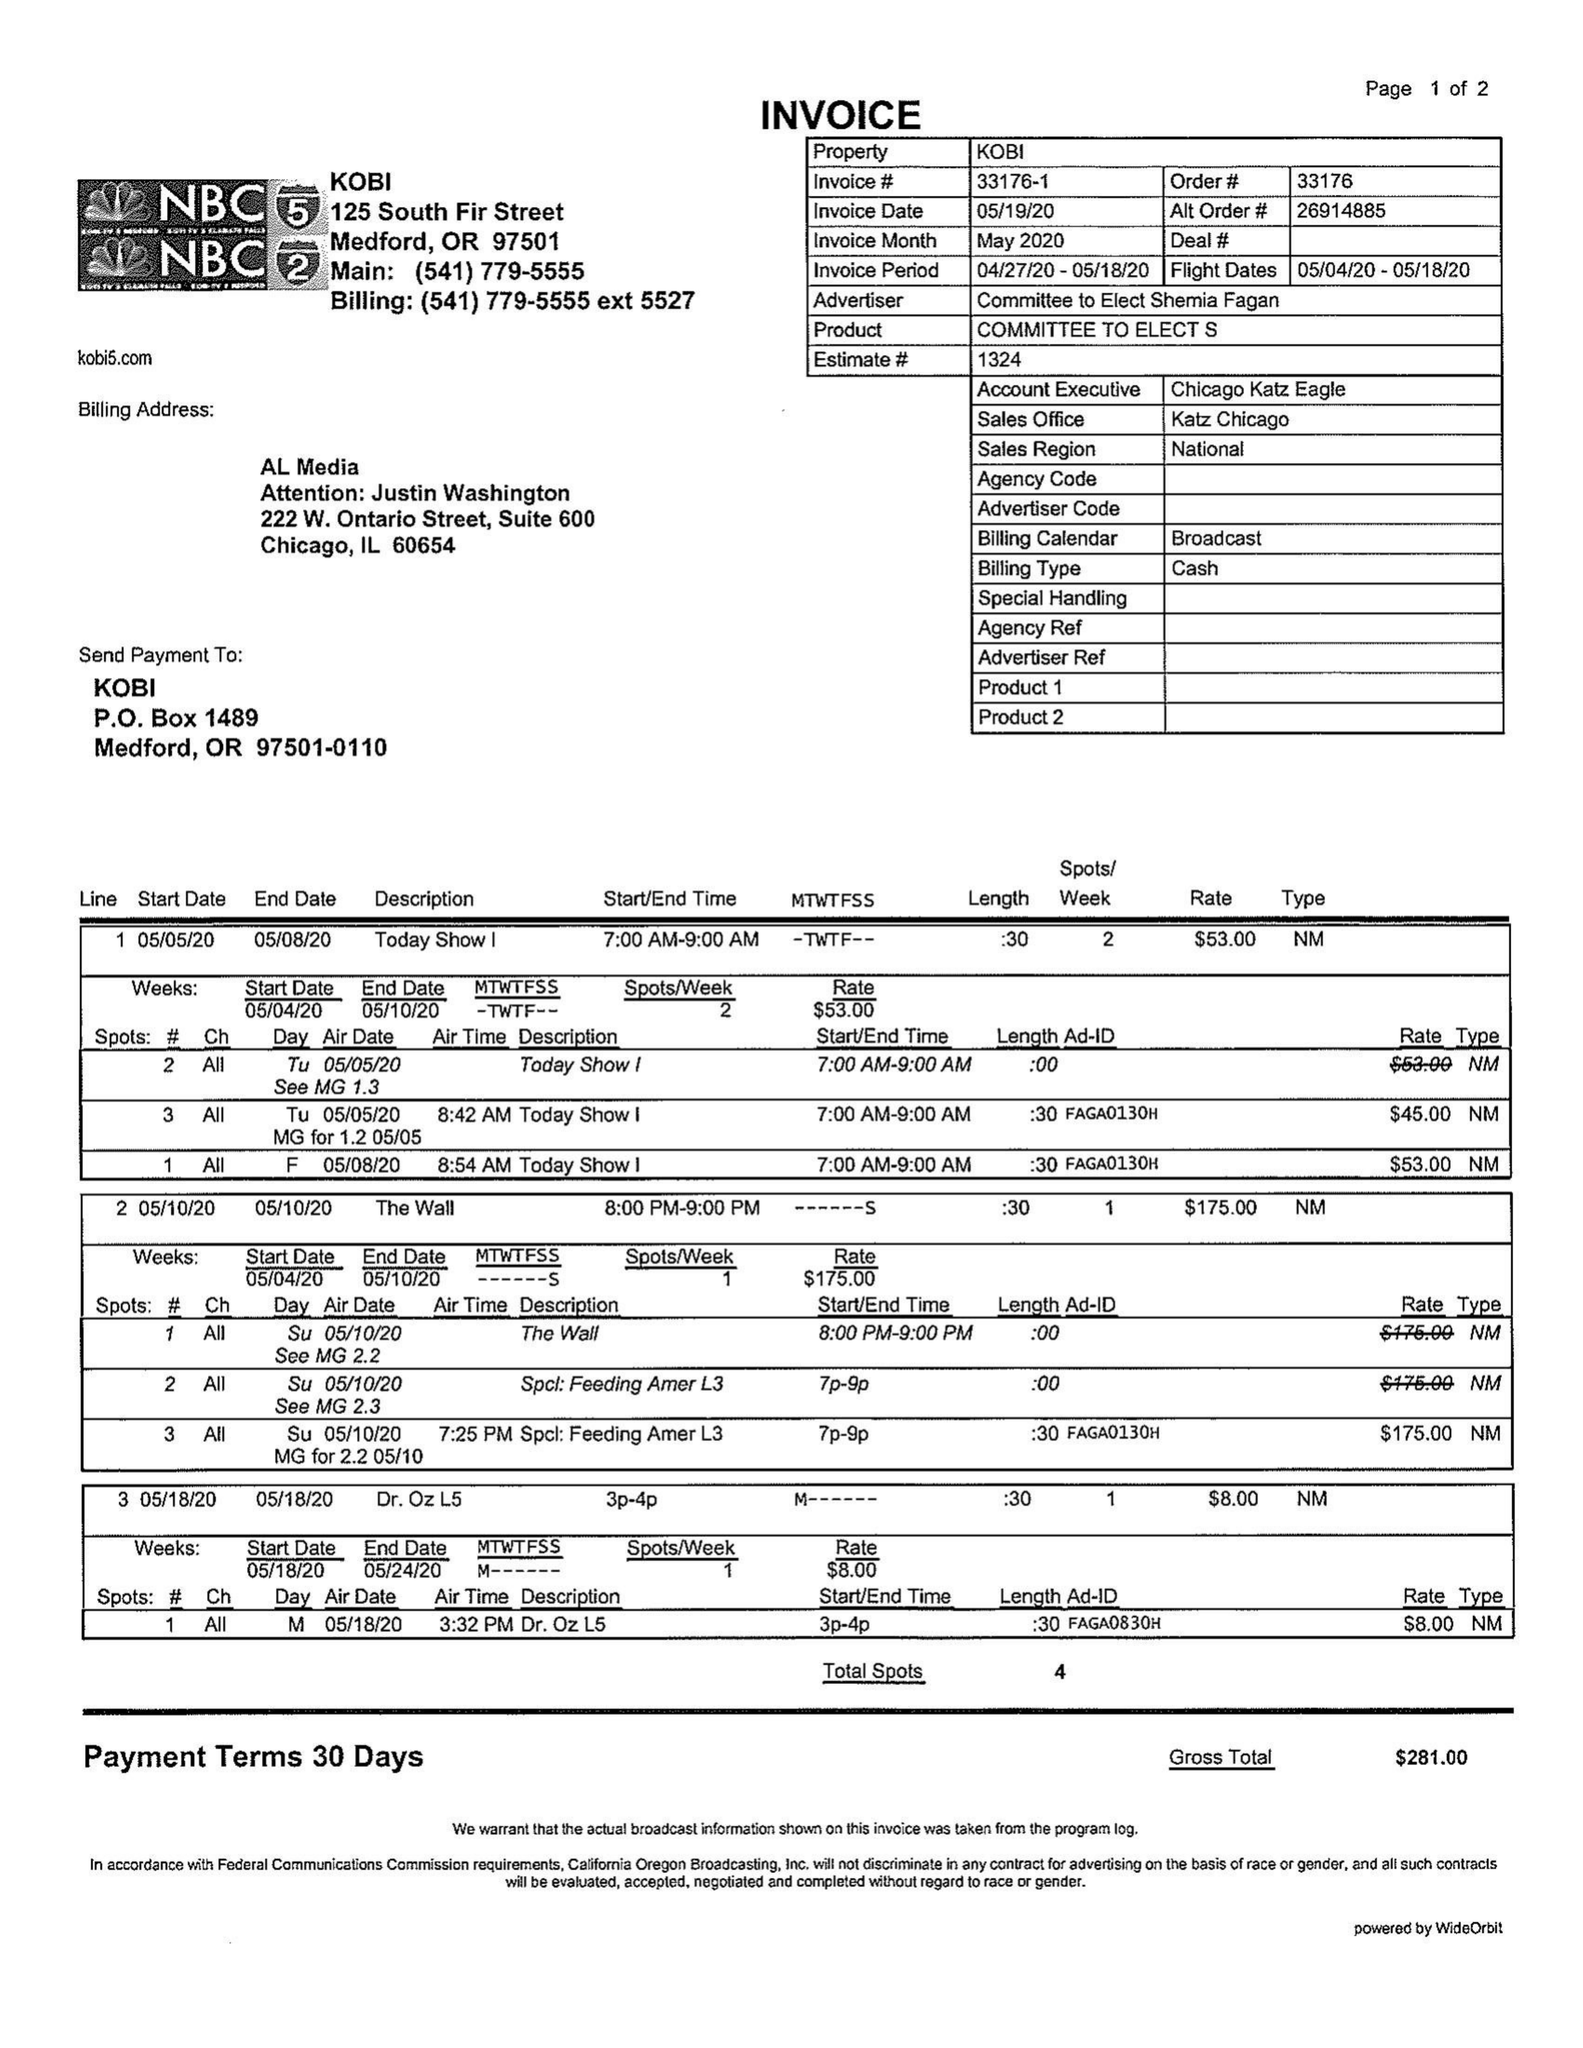What is the value for the flight_from?
Answer the question using a single word or phrase. 05/04/20 